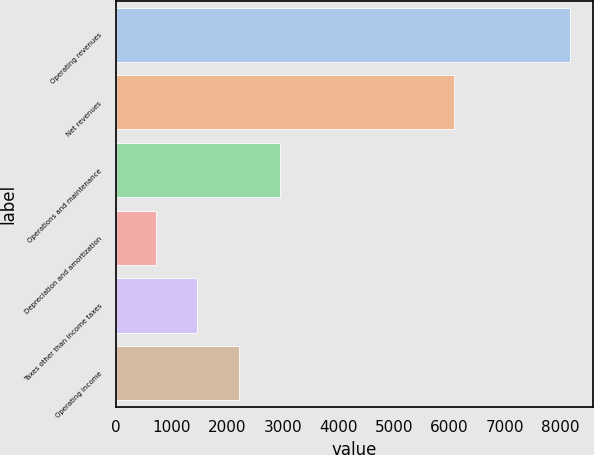<chart> <loc_0><loc_0><loc_500><loc_500><bar_chart><fcel>Operating revenues<fcel>Net revenues<fcel>Operations and maintenance<fcel>Depreciation and amortization<fcel>Taxes other than income taxes<fcel>Operating income<nl><fcel>8176<fcel>6079<fcel>2949.8<fcel>710<fcel>1456.6<fcel>2203.2<nl></chart> 